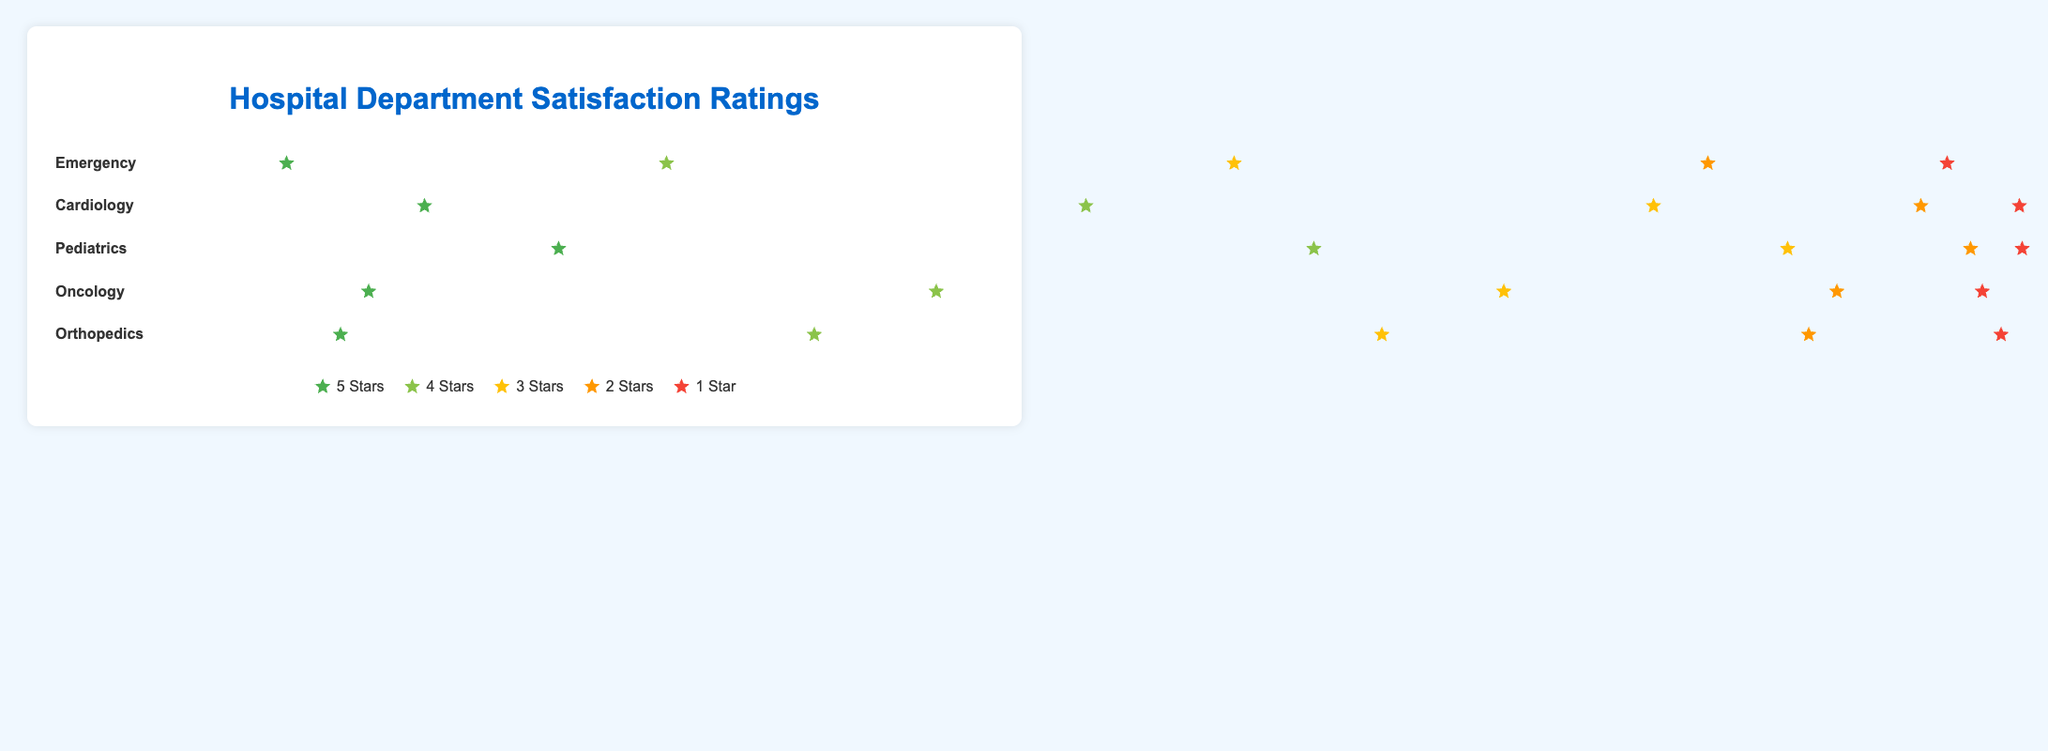what is the title of the figure? The title is typically placed at the top of the figure and serves to summarize the main topic or purpose of the figure. In this figure, the title is "Hospital Department Satisfaction Ratings".
Answer: Hospital Department Satisfaction Ratings How many departments are displayed in the figure? Count each department name listed vertically in the left side of the plot. There are five departments listed: Emergency, Cardiology, Pediatrics, Oncology, and Orthopedics.
Answer: Five Which department has the highest number of 5-star ratings? Check all the 5-star rating segments and compare their lengths visually or refer to the data directly. Pediatrics has a rating length of 900px (45 ratings), which is the longest.
Answer: Pediatrics How does the number of 1-star ratings in Emergency compare to that in Oncology? Look at the width of the 1-star rating segments for both departments. Emergency has a width of 200px (10 ratings), and Oncology has a width of 100px (5 ratings).
Answer: Emergency has double the number of 1-star ratings compared to Oncology What is the total number of ratings for Cardiology? Sum all ratings for Cardiology: 30 (5-star) + 40 (4-star) + 20 (3-star) + 8 (2-star) + 2 (1-star) = 100.
Answer: 100 Which department has the smallest amount of 3-star ratings? Compare the lengths of the 3-star rating bars visually. Pediatrics has the shortest with 300px (15 ratings) which is the least.
Answer: Pediatrics What is the total number of 2-star ratings across all departments? Add up the 2-star ratings for each department: 15 (Emergency) + 8 (Cardiology) + 4 (Pediatrics) + 10 (Oncology) + 15 (Orthopedics) = 52.
Answer: 52 Which two departments have the most similar distribution of ratings across all stars? Look at the visual patterns of the different star ratings for each department. Oncology and Orthopedics both have very similar visual distribution patterns.
Answer: Oncology and Orthopedics Which department had the most 4-star ratings? Compare the 4-star bars across departments. Cardiology has the longest 4-star rating bar with 800px (40 ratings).
Answer: Cardiology 